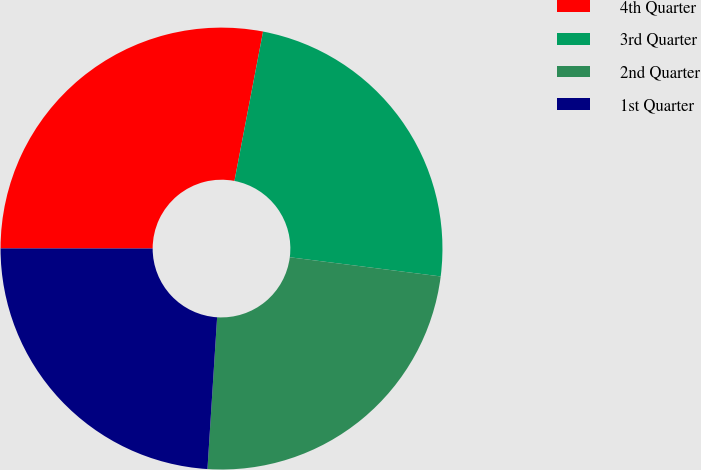Convert chart. <chart><loc_0><loc_0><loc_500><loc_500><pie_chart><fcel>4th Quarter<fcel>3rd Quarter<fcel>2nd Quarter<fcel>1st Quarter<nl><fcel>28.0%<fcel>24.0%<fcel>24.0%<fcel>24.0%<nl></chart> 